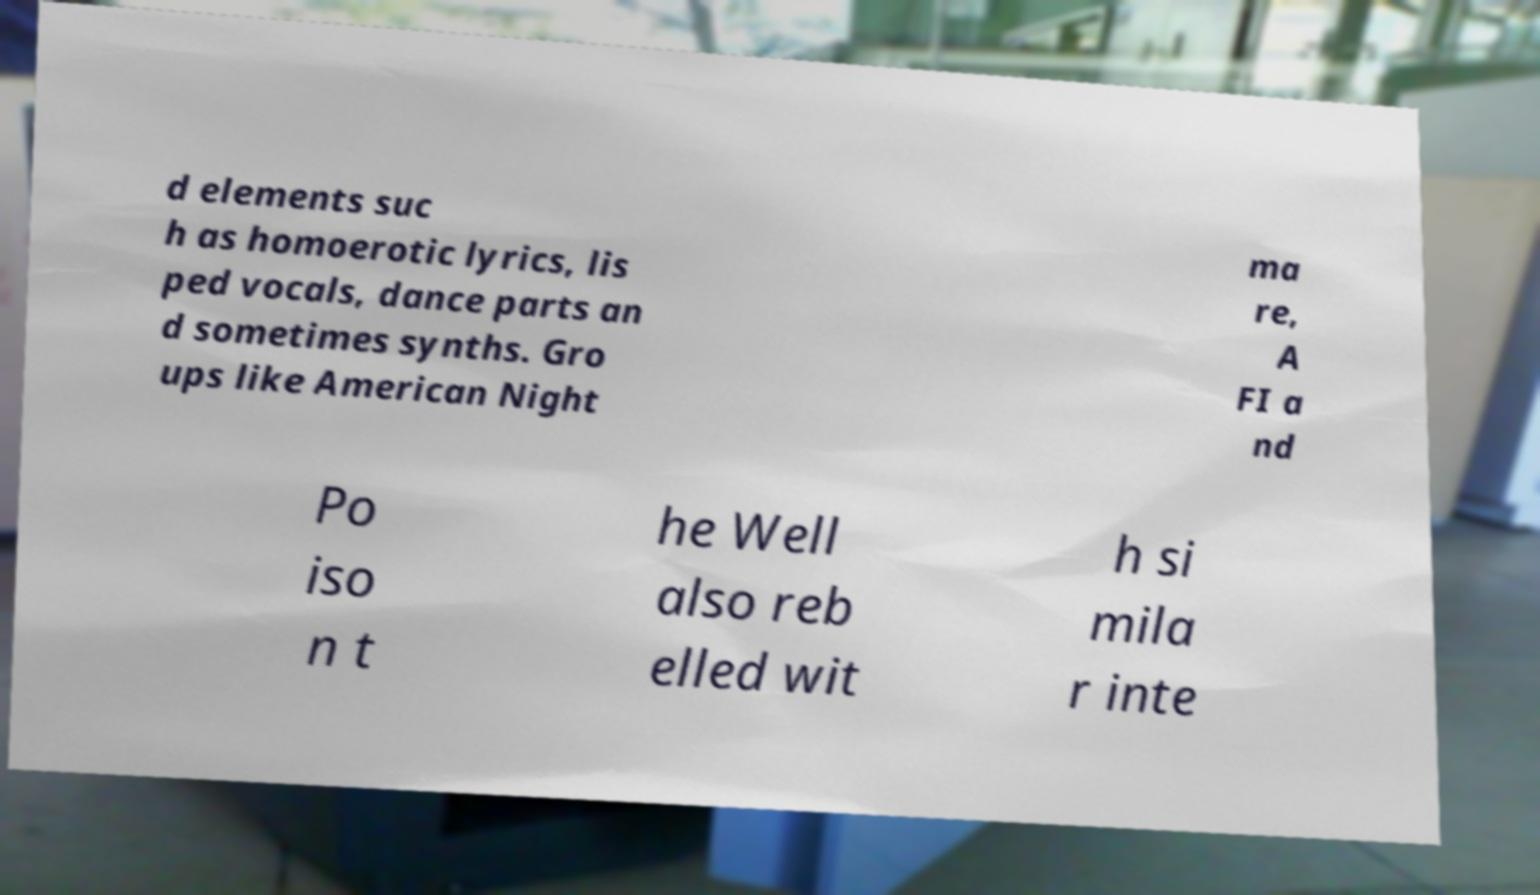For documentation purposes, I need the text within this image transcribed. Could you provide that? d elements suc h as homoerotic lyrics, lis ped vocals, dance parts an d sometimes synths. Gro ups like American Night ma re, A FI a nd Po iso n t he Well also reb elled wit h si mila r inte 